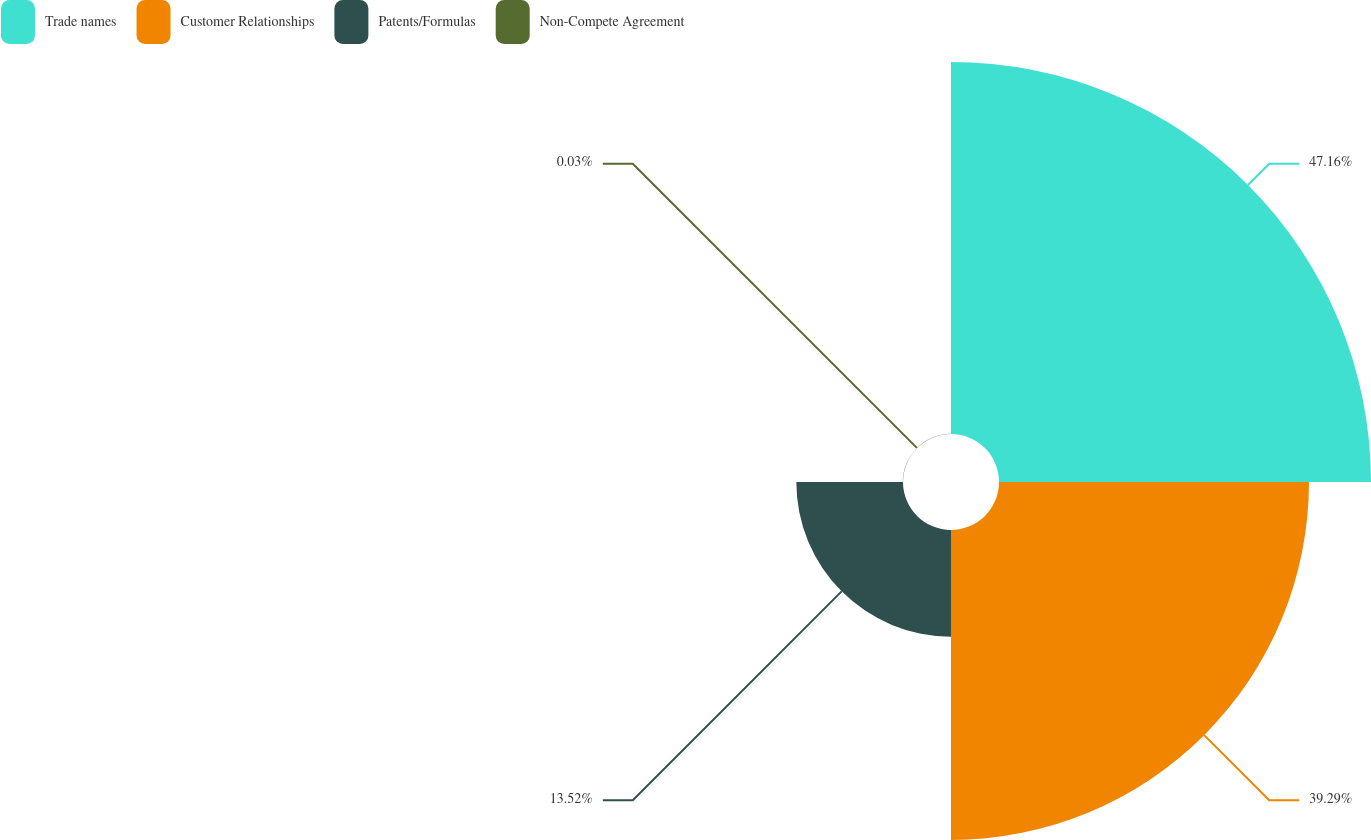Convert chart to OTSL. <chart><loc_0><loc_0><loc_500><loc_500><pie_chart><fcel>Trade names<fcel>Customer Relationships<fcel>Patents/Formulas<fcel>Non-Compete Agreement<nl><fcel>47.15%<fcel>39.29%<fcel>13.52%<fcel>0.03%<nl></chart> 